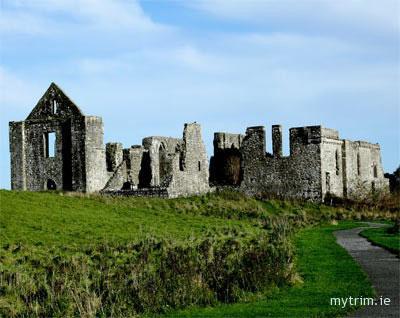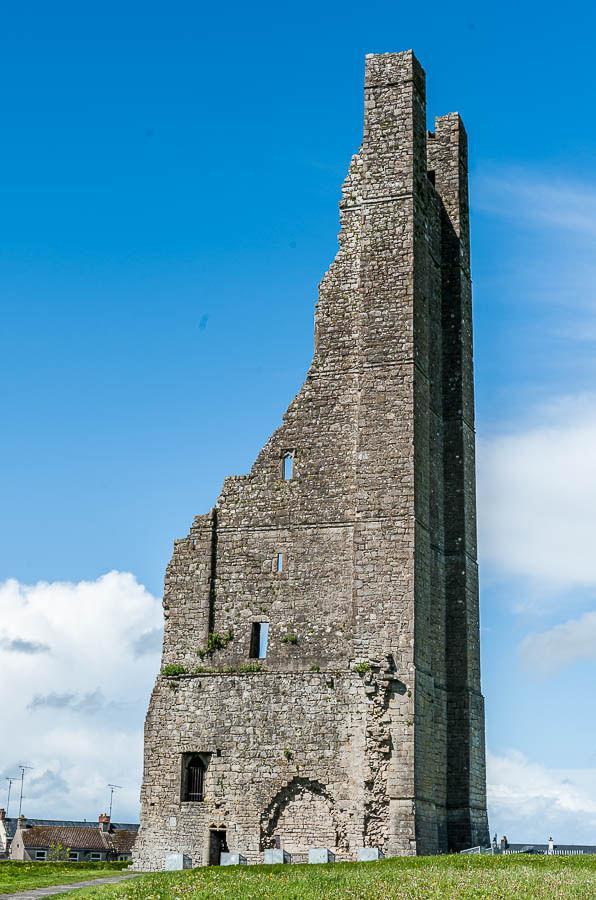The first image is the image on the left, the second image is the image on the right. Examine the images to the left and right. Is the description "The building in one of the images is near a body of water." accurate? Answer yes or no. No. 